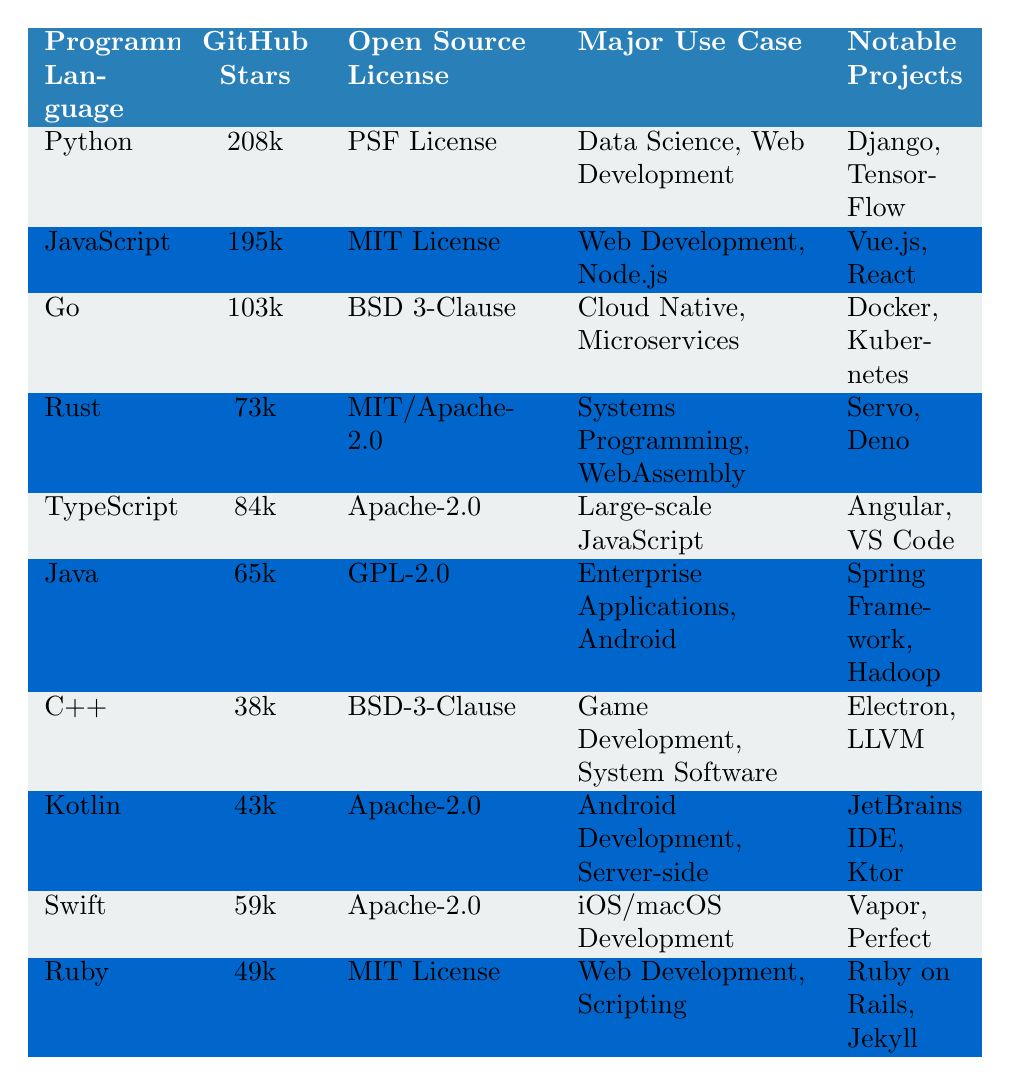What programming language has the most GitHub stars? The table shows that Python has the most GitHub stars, with a total of 208k.
Answer: Python Which open-source license is used by JavaScript? According to the table, JavaScript uses the MIT License.
Answer: MIT License How many GitHub stars does Go have? From the table, Go has 103k GitHub stars listed.
Answer: 103k Is Rust's notable project Deno? The table states that Deno is one of the notable projects for Rust.
Answer: Yes What is the major use case for Kotlin? The table indicates that Kotlin's major use case includes Android Development and Server-side applications.
Answer: Android Development, Server-side What programming language has the least GitHub stars among the ones listed? The table shows that C++ has the least GitHub stars with 38k.
Answer: C++ Which programming language has both cloud-native and microservices as major use cases? The table shows that Go has cloud-native and microservices listed as its major use case.
Answer: Go What is the sum of the GitHub stars for Java and Swift? The GitHub stars for Java (65k) and Swift (59k) are summed up: 65k + 59k = 124k.
Answer: 124k Does Ruby have more GitHub stars than Kotlin? The table shows that Ruby has 49k stars and Kotlin has 43k stars, indicating Ruby has more stars.
Answer: Yes What is the average number of GitHub stars for TypeScript, Java, and C++? The GitHub stars for TypeScript (84k), Java (65k), and C++ (38k) are summed up to give 84k + 65k + 38k = 187k. The average is 187k divided by 3, which equals approximately 62.33k.
Answer: 62.33k 